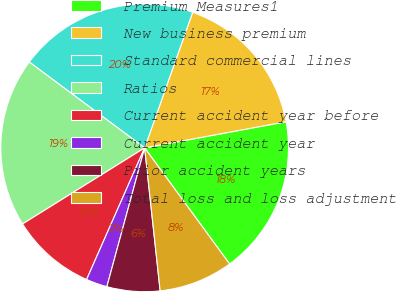<chart> <loc_0><loc_0><loc_500><loc_500><pie_chart><fcel>Premium Measures1<fcel>New business premium<fcel>Standard commercial lines<fcel>Ratios<fcel>Current accident year before<fcel>Current accident year<fcel>Prior accident years<fcel>Total loss and loss adjustment<nl><fcel>17.86%<fcel>16.67%<fcel>20.24%<fcel>19.05%<fcel>9.52%<fcel>2.38%<fcel>5.95%<fcel>8.33%<nl></chart> 